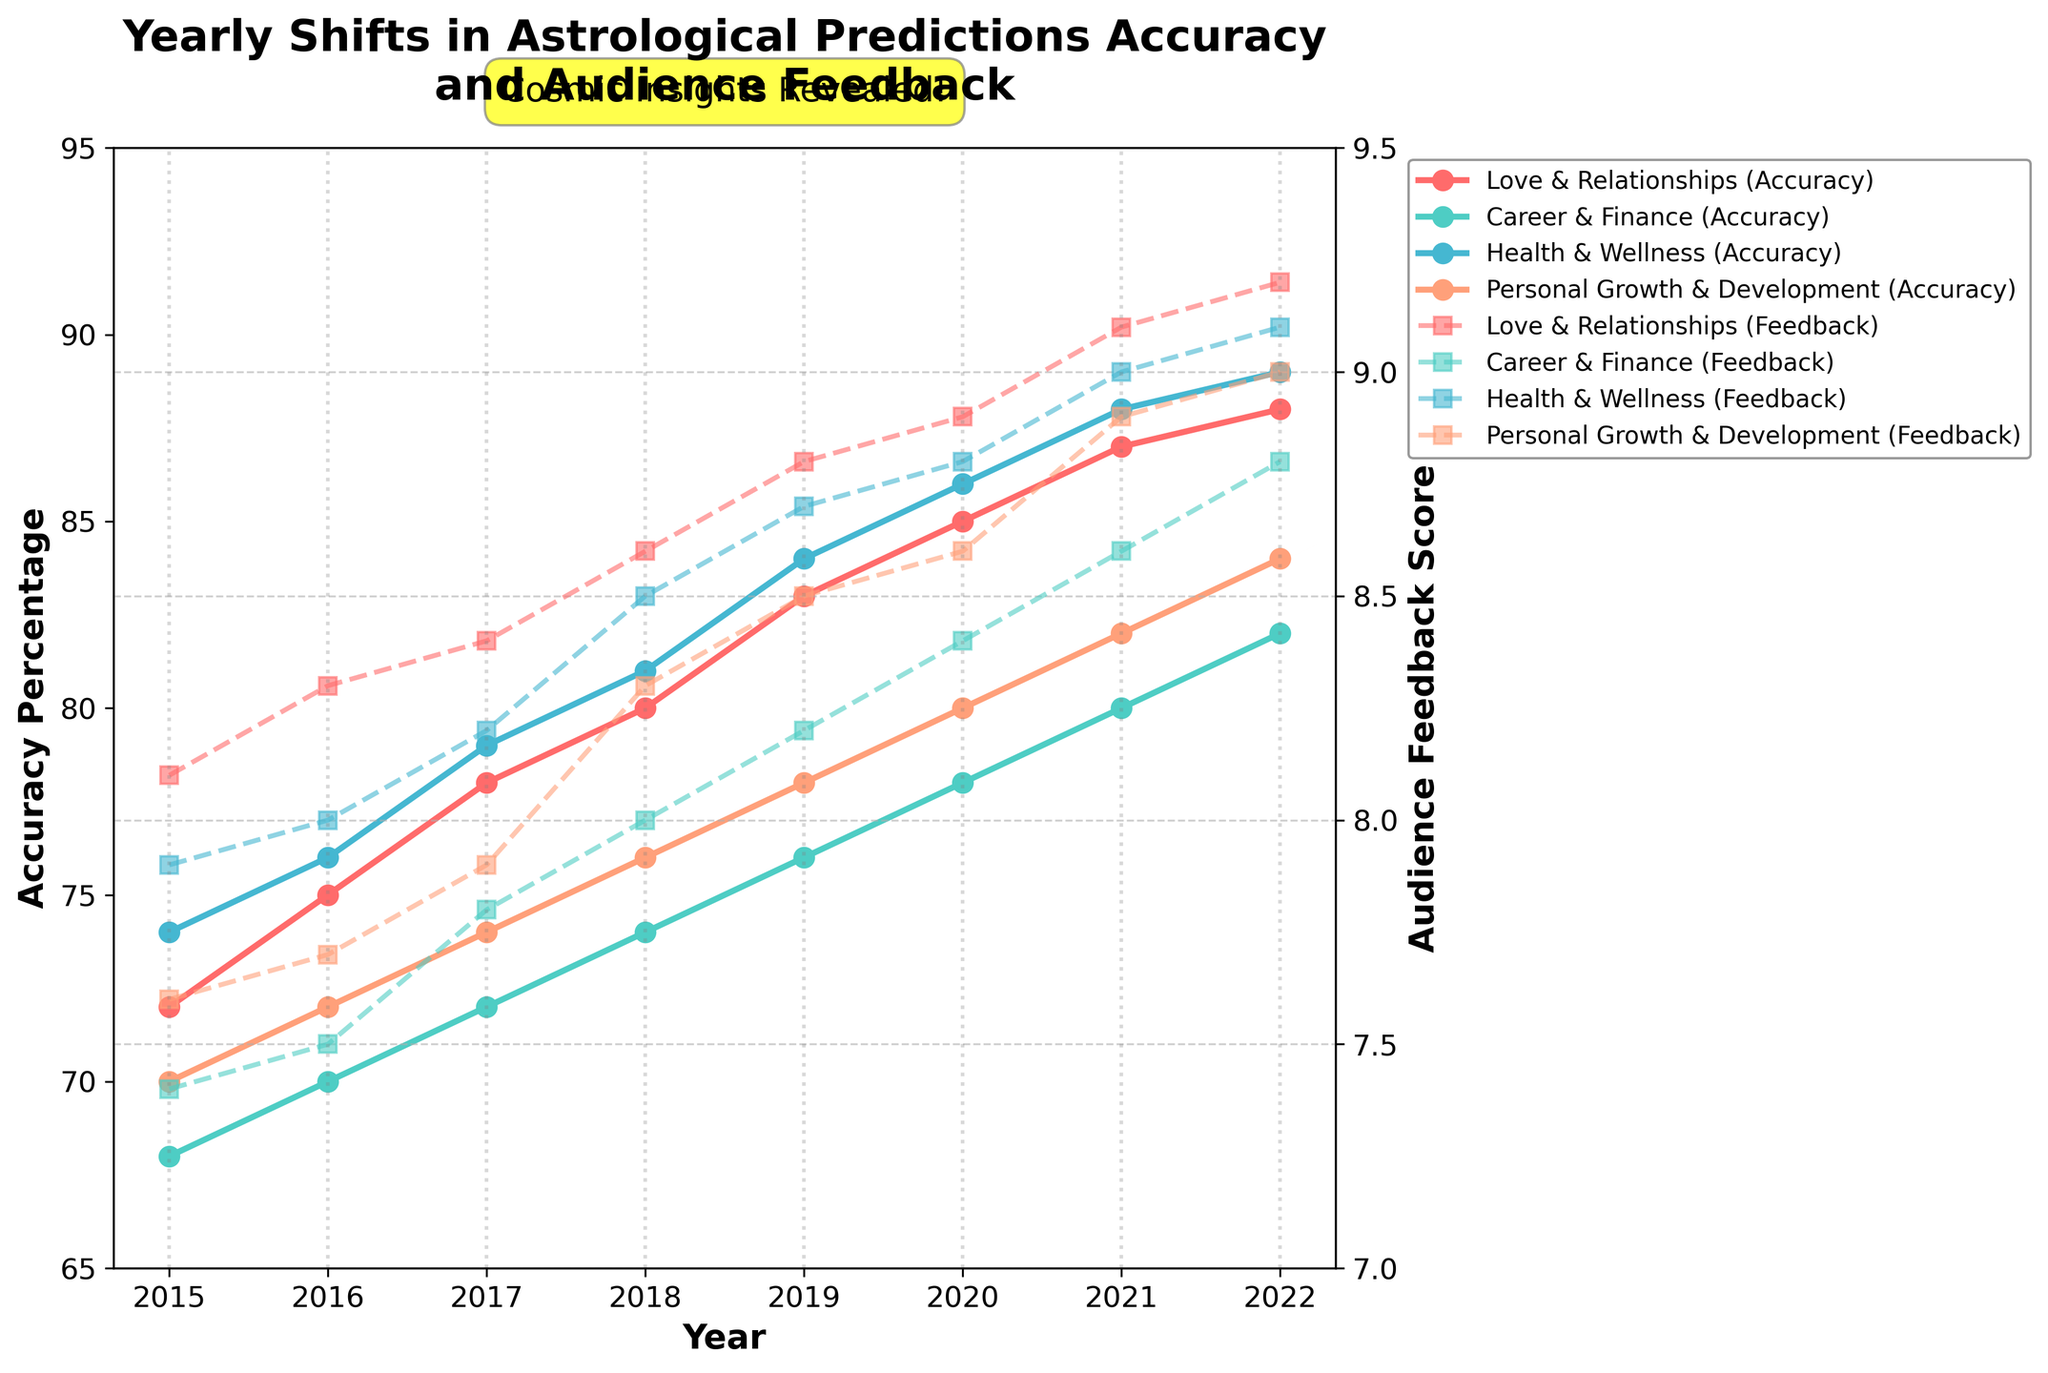What's the highest accuracy percentage for Love & Relationships? The highest accuracy percentage for each prediction area can be identified by looking at the peak points in the figure. For Love & Relationships, it peaks at 88% in 2022.
Answer: 88% How did the audience feedback score for Career & Finance change from 2015 to 2022? Observing the line for Career & Finance feedback from 2015 to 2022 shows a general upward trend from 7.4 to 8.8.
Answer: Increased from 7.4 to 8.8 Which prediction area had the highest audience feedback score in 2021? By comparing the high points of audience feedback scores for 2021, it's evident that Health & Wellness had the highest score at 9.0.
Answer: Health & Wellness What is the average accuracy percentage for Health & Wellness from 2015 to 2022? To calculate the average, add all the accuracy percentages for Health & Wellness from 2015 to 2022 (74 + 76 + 79 + 81 + 84 + 86 + 88 + 89) and divide by 8. (74 + 76 + 79 + 81 + 84 + 86 + 88 + 89) / 8 = 82.125
Answer: 82.125 Which year showed the biggest improvement in accuracy percentage for Personal Growth & Development compared to the previous year? By comparing each year’s change for Personal Growth & Development from the plot: 2016 (2%), 2017 (2%), 2018 (2%), 2019 (2%), 2020 (2%), 2021 (2%), 2022 (2%). The increase appears steady, but without any standout large jumps, consistent improvement is observed.
Answer: Consistent 2% yearly In which year did the audience feedback score for all prediction areas improve compared to the previous year? We observe the feedback scores year by year. In 2021, all prediction areas improved compared to 2020.
Answer: 2021 What is the difference between the accuracy percentage and audience feedback score for Health & Wellness in 2022? For Health & Wellness in 2022, the accuracy percentage is 89 and the audience feedback score is 9.1. Their difference is 89 - 9.1 = 79.9.
Answer: 79.9 Which prediction area showed the least variation in accuracy percentage over the years? By looking at the plots, Career & Finance has the least fluctuation in accuracy percentage from 68% to 82%, compared to other prediction areas.
Answer: Career & Finance 